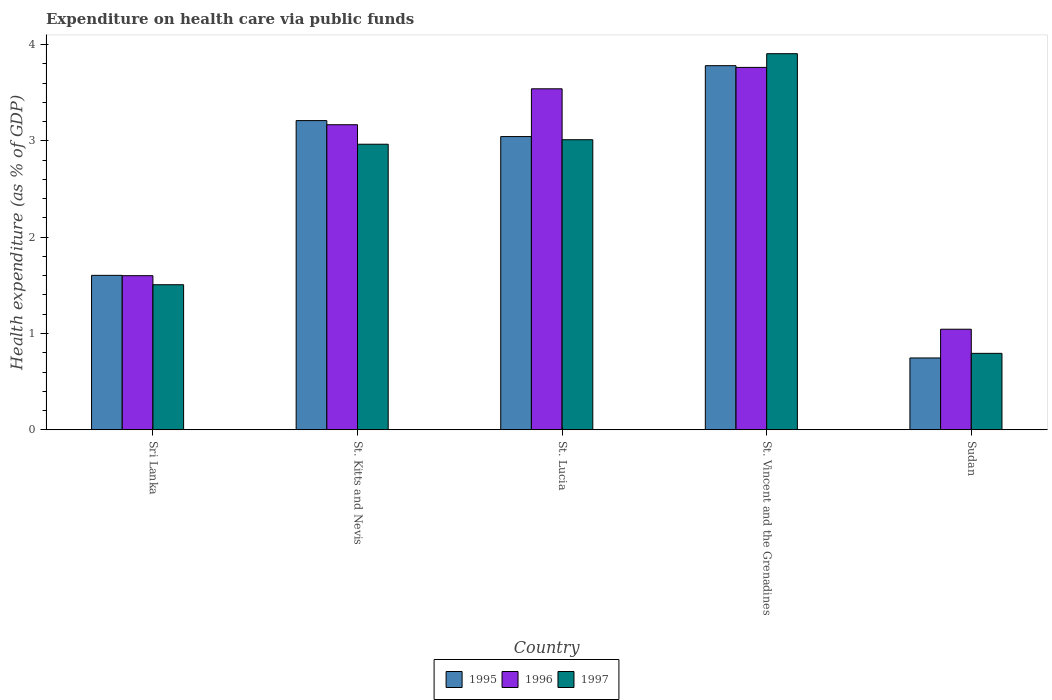How many different coloured bars are there?
Your answer should be compact. 3. Are the number of bars per tick equal to the number of legend labels?
Your answer should be compact. Yes. Are the number of bars on each tick of the X-axis equal?
Offer a very short reply. Yes. How many bars are there on the 1st tick from the left?
Give a very brief answer. 3. What is the label of the 2nd group of bars from the left?
Give a very brief answer. St. Kitts and Nevis. In how many cases, is the number of bars for a given country not equal to the number of legend labels?
Your response must be concise. 0. What is the expenditure made on health care in 1997 in Sri Lanka?
Ensure brevity in your answer.  1.51. Across all countries, what is the maximum expenditure made on health care in 1997?
Your answer should be compact. 3.91. Across all countries, what is the minimum expenditure made on health care in 1995?
Keep it short and to the point. 0.75. In which country was the expenditure made on health care in 1996 maximum?
Keep it short and to the point. St. Vincent and the Grenadines. In which country was the expenditure made on health care in 1995 minimum?
Offer a very short reply. Sudan. What is the total expenditure made on health care in 1996 in the graph?
Make the answer very short. 13.11. What is the difference between the expenditure made on health care in 1996 in Sri Lanka and that in St. Kitts and Nevis?
Ensure brevity in your answer.  -1.57. What is the difference between the expenditure made on health care in 1996 in St. Lucia and the expenditure made on health care in 1995 in Sri Lanka?
Your answer should be very brief. 1.94. What is the average expenditure made on health care in 1997 per country?
Ensure brevity in your answer.  2.44. What is the difference between the expenditure made on health care of/in 1996 and expenditure made on health care of/in 1997 in St. Kitts and Nevis?
Offer a very short reply. 0.2. What is the ratio of the expenditure made on health care in 1995 in St. Lucia to that in St. Vincent and the Grenadines?
Your answer should be compact. 0.81. Is the expenditure made on health care in 1997 in St. Lucia less than that in St. Vincent and the Grenadines?
Give a very brief answer. Yes. Is the difference between the expenditure made on health care in 1996 in St. Kitts and Nevis and St. Lucia greater than the difference between the expenditure made on health care in 1997 in St. Kitts and Nevis and St. Lucia?
Your answer should be very brief. No. What is the difference between the highest and the second highest expenditure made on health care in 1997?
Keep it short and to the point. 0.05. What is the difference between the highest and the lowest expenditure made on health care in 1996?
Provide a short and direct response. 2.72. Is the sum of the expenditure made on health care in 1995 in Sri Lanka and Sudan greater than the maximum expenditure made on health care in 1996 across all countries?
Your response must be concise. No. What does the 1st bar from the left in St. Lucia represents?
Give a very brief answer. 1995. What does the 3rd bar from the right in St. Lucia represents?
Make the answer very short. 1995. How many legend labels are there?
Your answer should be compact. 3. What is the title of the graph?
Make the answer very short. Expenditure on health care via public funds. What is the label or title of the X-axis?
Keep it short and to the point. Country. What is the label or title of the Y-axis?
Ensure brevity in your answer.  Health expenditure (as % of GDP). What is the Health expenditure (as % of GDP) of 1995 in Sri Lanka?
Keep it short and to the point. 1.6. What is the Health expenditure (as % of GDP) of 1996 in Sri Lanka?
Offer a very short reply. 1.6. What is the Health expenditure (as % of GDP) of 1997 in Sri Lanka?
Your answer should be very brief. 1.51. What is the Health expenditure (as % of GDP) of 1995 in St. Kitts and Nevis?
Provide a short and direct response. 3.21. What is the Health expenditure (as % of GDP) of 1996 in St. Kitts and Nevis?
Give a very brief answer. 3.17. What is the Health expenditure (as % of GDP) of 1997 in St. Kitts and Nevis?
Offer a very short reply. 2.96. What is the Health expenditure (as % of GDP) in 1995 in St. Lucia?
Offer a very short reply. 3.04. What is the Health expenditure (as % of GDP) of 1996 in St. Lucia?
Give a very brief answer. 3.54. What is the Health expenditure (as % of GDP) of 1997 in St. Lucia?
Offer a terse response. 3.01. What is the Health expenditure (as % of GDP) in 1995 in St. Vincent and the Grenadines?
Offer a terse response. 3.78. What is the Health expenditure (as % of GDP) in 1996 in St. Vincent and the Grenadines?
Offer a very short reply. 3.76. What is the Health expenditure (as % of GDP) in 1997 in St. Vincent and the Grenadines?
Your answer should be very brief. 3.91. What is the Health expenditure (as % of GDP) in 1995 in Sudan?
Offer a terse response. 0.75. What is the Health expenditure (as % of GDP) in 1996 in Sudan?
Your response must be concise. 1.04. What is the Health expenditure (as % of GDP) in 1997 in Sudan?
Ensure brevity in your answer.  0.79. Across all countries, what is the maximum Health expenditure (as % of GDP) in 1995?
Make the answer very short. 3.78. Across all countries, what is the maximum Health expenditure (as % of GDP) of 1996?
Keep it short and to the point. 3.76. Across all countries, what is the maximum Health expenditure (as % of GDP) of 1997?
Your answer should be very brief. 3.91. Across all countries, what is the minimum Health expenditure (as % of GDP) of 1995?
Offer a very short reply. 0.75. Across all countries, what is the minimum Health expenditure (as % of GDP) of 1996?
Your answer should be very brief. 1.04. Across all countries, what is the minimum Health expenditure (as % of GDP) in 1997?
Your response must be concise. 0.79. What is the total Health expenditure (as % of GDP) of 1995 in the graph?
Your response must be concise. 12.38. What is the total Health expenditure (as % of GDP) of 1996 in the graph?
Your answer should be very brief. 13.11. What is the total Health expenditure (as % of GDP) of 1997 in the graph?
Keep it short and to the point. 12.18. What is the difference between the Health expenditure (as % of GDP) in 1995 in Sri Lanka and that in St. Kitts and Nevis?
Make the answer very short. -1.61. What is the difference between the Health expenditure (as % of GDP) of 1996 in Sri Lanka and that in St. Kitts and Nevis?
Keep it short and to the point. -1.57. What is the difference between the Health expenditure (as % of GDP) of 1997 in Sri Lanka and that in St. Kitts and Nevis?
Your answer should be very brief. -1.46. What is the difference between the Health expenditure (as % of GDP) in 1995 in Sri Lanka and that in St. Lucia?
Offer a very short reply. -1.44. What is the difference between the Health expenditure (as % of GDP) in 1996 in Sri Lanka and that in St. Lucia?
Your answer should be compact. -1.94. What is the difference between the Health expenditure (as % of GDP) of 1997 in Sri Lanka and that in St. Lucia?
Give a very brief answer. -1.51. What is the difference between the Health expenditure (as % of GDP) in 1995 in Sri Lanka and that in St. Vincent and the Grenadines?
Provide a succinct answer. -2.18. What is the difference between the Health expenditure (as % of GDP) of 1996 in Sri Lanka and that in St. Vincent and the Grenadines?
Give a very brief answer. -2.16. What is the difference between the Health expenditure (as % of GDP) of 1997 in Sri Lanka and that in St. Vincent and the Grenadines?
Ensure brevity in your answer.  -2.4. What is the difference between the Health expenditure (as % of GDP) in 1995 in Sri Lanka and that in Sudan?
Offer a very short reply. 0.86. What is the difference between the Health expenditure (as % of GDP) in 1996 in Sri Lanka and that in Sudan?
Offer a terse response. 0.56. What is the difference between the Health expenditure (as % of GDP) in 1997 in Sri Lanka and that in Sudan?
Provide a succinct answer. 0.71. What is the difference between the Health expenditure (as % of GDP) in 1995 in St. Kitts and Nevis and that in St. Lucia?
Provide a succinct answer. 0.17. What is the difference between the Health expenditure (as % of GDP) in 1996 in St. Kitts and Nevis and that in St. Lucia?
Give a very brief answer. -0.37. What is the difference between the Health expenditure (as % of GDP) of 1997 in St. Kitts and Nevis and that in St. Lucia?
Make the answer very short. -0.05. What is the difference between the Health expenditure (as % of GDP) in 1995 in St. Kitts and Nevis and that in St. Vincent and the Grenadines?
Offer a very short reply. -0.57. What is the difference between the Health expenditure (as % of GDP) in 1996 in St. Kitts and Nevis and that in St. Vincent and the Grenadines?
Your answer should be very brief. -0.6. What is the difference between the Health expenditure (as % of GDP) in 1997 in St. Kitts and Nevis and that in St. Vincent and the Grenadines?
Your answer should be compact. -0.94. What is the difference between the Health expenditure (as % of GDP) in 1995 in St. Kitts and Nevis and that in Sudan?
Offer a very short reply. 2.46. What is the difference between the Health expenditure (as % of GDP) of 1996 in St. Kitts and Nevis and that in Sudan?
Your response must be concise. 2.12. What is the difference between the Health expenditure (as % of GDP) of 1997 in St. Kitts and Nevis and that in Sudan?
Your response must be concise. 2.17. What is the difference between the Health expenditure (as % of GDP) in 1995 in St. Lucia and that in St. Vincent and the Grenadines?
Provide a succinct answer. -0.74. What is the difference between the Health expenditure (as % of GDP) of 1996 in St. Lucia and that in St. Vincent and the Grenadines?
Offer a very short reply. -0.22. What is the difference between the Health expenditure (as % of GDP) of 1997 in St. Lucia and that in St. Vincent and the Grenadines?
Ensure brevity in your answer.  -0.89. What is the difference between the Health expenditure (as % of GDP) in 1995 in St. Lucia and that in Sudan?
Your response must be concise. 2.3. What is the difference between the Health expenditure (as % of GDP) in 1996 in St. Lucia and that in Sudan?
Ensure brevity in your answer.  2.5. What is the difference between the Health expenditure (as % of GDP) of 1997 in St. Lucia and that in Sudan?
Your response must be concise. 2.22. What is the difference between the Health expenditure (as % of GDP) in 1995 in St. Vincent and the Grenadines and that in Sudan?
Provide a short and direct response. 3.03. What is the difference between the Health expenditure (as % of GDP) in 1996 in St. Vincent and the Grenadines and that in Sudan?
Your response must be concise. 2.72. What is the difference between the Health expenditure (as % of GDP) in 1997 in St. Vincent and the Grenadines and that in Sudan?
Provide a succinct answer. 3.11. What is the difference between the Health expenditure (as % of GDP) in 1995 in Sri Lanka and the Health expenditure (as % of GDP) in 1996 in St. Kitts and Nevis?
Provide a succinct answer. -1.56. What is the difference between the Health expenditure (as % of GDP) in 1995 in Sri Lanka and the Health expenditure (as % of GDP) in 1997 in St. Kitts and Nevis?
Your answer should be compact. -1.36. What is the difference between the Health expenditure (as % of GDP) of 1996 in Sri Lanka and the Health expenditure (as % of GDP) of 1997 in St. Kitts and Nevis?
Your answer should be compact. -1.36. What is the difference between the Health expenditure (as % of GDP) of 1995 in Sri Lanka and the Health expenditure (as % of GDP) of 1996 in St. Lucia?
Your response must be concise. -1.94. What is the difference between the Health expenditure (as % of GDP) of 1995 in Sri Lanka and the Health expenditure (as % of GDP) of 1997 in St. Lucia?
Keep it short and to the point. -1.41. What is the difference between the Health expenditure (as % of GDP) of 1996 in Sri Lanka and the Health expenditure (as % of GDP) of 1997 in St. Lucia?
Offer a very short reply. -1.41. What is the difference between the Health expenditure (as % of GDP) of 1995 in Sri Lanka and the Health expenditure (as % of GDP) of 1996 in St. Vincent and the Grenadines?
Offer a very short reply. -2.16. What is the difference between the Health expenditure (as % of GDP) of 1995 in Sri Lanka and the Health expenditure (as % of GDP) of 1997 in St. Vincent and the Grenadines?
Offer a very short reply. -2.3. What is the difference between the Health expenditure (as % of GDP) of 1996 in Sri Lanka and the Health expenditure (as % of GDP) of 1997 in St. Vincent and the Grenadines?
Your answer should be very brief. -2.3. What is the difference between the Health expenditure (as % of GDP) in 1995 in Sri Lanka and the Health expenditure (as % of GDP) in 1996 in Sudan?
Your answer should be very brief. 0.56. What is the difference between the Health expenditure (as % of GDP) in 1995 in Sri Lanka and the Health expenditure (as % of GDP) in 1997 in Sudan?
Ensure brevity in your answer.  0.81. What is the difference between the Health expenditure (as % of GDP) in 1996 in Sri Lanka and the Health expenditure (as % of GDP) in 1997 in Sudan?
Provide a short and direct response. 0.81. What is the difference between the Health expenditure (as % of GDP) in 1995 in St. Kitts and Nevis and the Health expenditure (as % of GDP) in 1996 in St. Lucia?
Your answer should be very brief. -0.33. What is the difference between the Health expenditure (as % of GDP) in 1995 in St. Kitts and Nevis and the Health expenditure (as % of GDP) in 1997 in St. Lucia?
Offer a terse response. 0.2. What is the difference between the Health expenditure (as % of GDP) of 1996 in St. Kitts and Nevis and the Health expenditure (as % of GDP) of 1997 in St. Lucia?
Provide a short and direct response. 0.16. What is the difference between the Health expenditure (as % of GDP) of 1995 in St. Kitts and Nevis and the Health expenditure (as % of GDP) of 1996 in St. Vincent and the Grenadines?
Your answer should be compact. -0.55. What is the difference between the Health expenditure (as % of GDP) of 1995 in St. Kitts and Nevis and the Health expenditure (as % of GDP) of 1997 in St. Vincent and the Grenadines?
Your response must be concise. -0.69. What is the difference between the Health expenditure (as % of GDP) in 1996 in St. Kitts and Nevis and the Health expenditure (as % of GDP) in 1997 in St. Vincent and the Grenadines?
Keep it short and to the point. -0.74. What is the difference between the Health expenditure (as % of GDP) in 1995 in St. Kitts and Nevis and the Health expenditure (as % of GDP) in 1996 in Sudan?
Provide a succinct answer. 2.17. What is the difference between the Health expenditure (as % of GDP) of 1995 in St. Kitts and Nevis and the Health expenditure (as % of GDP) of 1997 in Sudan?
Ensure brevity in your answer.  2.42. What is the difference between the Health expenditure (as % of GDP) in 1996 in St. Kitts and Nevis and the Health expenditure (as % of GDP) in 1997 in Sudan?
Offer a very short reply. 2.37. What is the difference between the Health expenditure (as % of GDP) in 1995 in St. Lucia and the Health expenditure (as % of GDP) in 1996 in St. Vincent and the Grenadines?
Give a very brief answer. -0.72. What is the difference between the Health expenditure (as % of GDP) in 1995 in St. Lucia and the Health expenditure (as % of GDP) in 1997 in St. Vincent and the Grenadines?
Make the answer very short. -0.86. What is the difference between the Health expenditure (as % of GDP) in 1996 in St. Lucia and the Health expenditure (as % of GDP) in 1997 in St. Vincent and the Grenadines?
Ensure brevity in your answer.  -0.36. What is the difference between the Health expenditure (as % of GDP) of 1995 in St. Lucia and the Health expenditure (as % of GDP) of 1996 in Sudan?
Your response must be concise. 2. What is the difference between the Health expenditure (as % of GDP) of 1995 in St. Lucia and the Health expenditure (as % of GDP) of 1997 in Sudan?
Ensure brevity in your answer.  2.25. What is the difference between the Health expenditure (as % of GDP) of 1996 in St. Lucia and the Health expenditure (as % of GDP) of 1997 in Sudan?
Give a very brief answer. 2.75. What is the difference between the Health expenditure (as % of GDP) of 1995 in St. Vincent and the Grenadines and the Health expenditure (as % of GDP) of 1996 in Sudan?
Provide a short and direct response. 2.74. What is the difference between the Health expenditure (as % of GDP) in 1995 in St. Vincent and the Grenadines and the Health expenditure (as % of GDP) in 1997 in Sudan?
Give a very brief answer. 2.99. What is the difference between the Health expenditure (as % of GDP) of 1996 in St. Vincent and the Grenadines and the Health expenditure (as % of GDP) of 1997 in Sudan?
Provide a short and direct response. 2.97. What is the average Health expenditure (as % of GDP) of 1995 per country?
Make the answer very short. 2.48. What is the average Health expenditure (as % of GDP) in 1996 per country?
Make the answer very short. 2.62. What is the average Health expenditure (as % of GDP) in 1997 per country?
Keep it short and to the point. 2.44. What is the difference between the Health expenditure (as % of GDP) of 1995 and Health expenditure (as % of GDP) of 1996 in Sri Lanka?
Offer a very short reply. 0. What is the difference between the Health expenditure (as % of GDP) of 1995 and Health expenditure (as % of GDP) of 1997 in Sri Lanka?
Make the answer very short. 0.1. What is the difference between the Health expenditure (as % of GDP) of 1996 and Health expenditure (as % of GDP) of 1997 in Sri Lanka?
Offer a terse response. 0.09. What is the difference between the Health expenditure (as % of GDP) of 1995 and Health expenditure (as % of GDP) of 1996 in St. Kitts and Nevis?
Keep it short and to the point. 0.04. What is the difference between the Health expenditure (as % of GDP) of 1995 and Health expenditure (as % of GDP) of 1997 in St. Kitts and Nevis?
Offer a terse response. 0.25. What is the difference between the Health expenditure (as % of GDP) of 1996 and Health expenditure (as % of GDP) of 1997 in St. Kitts and Nevis?
Keep it short and to the point. 0.2. What is the difference between the Health expenditure (as % of GDP) in 1995 and Health expenditure (as % of GDP) in 1996 in St. Lucia?
Ensure brevity in your answer.  -0.5. What is the difference between the Health expenditure (as % of GDP) in 1995 and Health expenditure (as % of GDP) in 1997 in St. Lucia?
Provide a short and direct response. 0.03. What is the difference between the Health expenditure (as % of GDP) of 1996 and Health expenditure (as % of GDP) of 1997 in St. Lucia?
Offer a terse response. 0.53. What is the difference between the Health expenditure (as % of GDP) of 1995 and Health expenditure (as % of GDP) of 1996 in St. Vincent and the Grenadines?
Your answer should be compact. 0.02. What is the difference between the Health expenditure (as % of GDP) in 1995 and Health expenditure (as % of GDP) in 1997 in St. Vincent and the Grenadines?
Ensure brevity in your answer.  -0.12. What is the difference between the Health expenditure (as % of GDP) in 1996 and Health expenditure (as % of GDP) in 1997 in St. Vincent and the Grenadines?
Ensure brevity in your answer.  -0.14. What is the difference between the Health expenditure (as % of GDP) of 1995 and Health expenditure (as % of GDP) of 1996 in Sudan?
Your answer should be compact. -0.3. What is the difference between the Health expenditure (as % of GDP) in 1995 and Health expenditure (as % of GDP) in 1997 in Sudan?
Offer a very short reply. -0.05. What is the difference between the Health expenditure (as % of GDP) in 1996 and Health expenditure (as % of GDP) in 1997 in Sudan?
Give a very brief answer. 0.25. What is the ratio of the Health expenditure (as % of GDP) in 1995 in Sri Lanka to that in St. Kitts and Nevis?
Make the answer very short. 0.5. What is the ratio of the Health expenditure (as % of GDP) of 1996 in Sri Lanka to that in St. Kitts and Nevis?
Make the answer very short. 0.51. What is the ratio of the Health expenditure (as % of GDP) of 1997 in Sri Lanka to that in St. Kitts and Nevis?
Your response must be concise. 0.51. What is the ratio of the Health expenditure (as % of GDP) in 1995 in Sri Lanka to that in St. Lucia?
Your response must be concise. 0.53. What is the ratio of the Health expenditure (as % of GDP) of 1996 in Sri Lanka to that in St. Lucia?
Provide a short and direct response. 0.45. What is the ratio of the Health expenditure (as % of GDP) in 1997 in Sri Lanka to that in St. Lucia?
Your answer should be compact. 0.5. What is the ratio of the Health expenditure (as % of GDP) of 1995 in Sri Lanka to that in St. Vincent and the Grenadines?
Give a very brief answer. 0.42. What is the ratio of the Health expenditure (as % of GDP) in 1996 in Sri Lanka to that in St. Vincent and the Grenadines?
Keep it short and to the point. 0.43. What is the ratio of the Health expenditure (as % of GDP) of 1997 in Sri Lanka to that in St. Vincent and the Grenadines?
Provide a short and direct response. 0.39. What is the ratio of the Health expenditure (as % of GDP) in 1995 in Sri Lanka to that in Sudan?
Provide a short and direct response. 2.15. What is the ratio of the Health expenditure (as % of GDP) in 1996 in Sri Lanka to that in Sudan?
Your response must be concise. 1.53. What is the ratio of the Health expenditure (as % of GDP) of 1997 in Sri Lanka to that in Sudan?
Provide a succinct answer. 1.9. What is the ratio of the Health expenditure (as % of GDP) in 1995 in St. Kitts and Nevis to that in St. Lucia?
Make the answer very short. 1.05. What is the ratio of the Health expenditure (as % of GDP) in 1996 in St. Kitts and Nevis to that in St. Lucia?
Your answer should be compact. 0.89. What is the ratio of the Health expenditure (as % of GDP) of 1997 in St. Kitts and Nevis to that in St. Lucia?
Provide a succinct answer. 0.98. What is the ratio of the Health expenditure (as % of GDP) of 1995 in St. Kitts and Nevis to that in St. Vincent and the Grenadines?
Offer a terse response. 0.85. What is the ratio of the Health expenditure (as % of GDP) of 1996 in St. Kitts and Nevis to that in St. Vincent and the Grenadines?
Make the answer very short. 0.84. What is the ratio of the Health expenditure (as % of GDP) of 1997 in St. Kitts and Nevis to that in St. Vincent and the Grenadines?
Ensure brevity in your answer.  0.76. What is the ratio of the Health expenditure (as % of GDP) in 1995 in St. Kitts and Nevis to that in Sudan?
Give a very brief answer. 4.3. What is the ratio of the Health expenditure (as % of GDP) in 1996 in St. Kitts and Nevis to that in Sudan?
Offer a very short reply. 3.03. What is the ratio of the Health expenditure (as % of GDP) of 1997 in St. Kitts and Nevis to that in Sudan?
Offer a terse response. 3.74. What is the ratio of the Health expenditure (as % of GDP) in 1995 in St. Lucia to that in St. Vincent and the Grenadines?
Offer a terse response. 0.81. What is the ratio of the Health expenditure (as % of GDP) in 1996 in St. Lucia to that in St. Vincent and the Grenadines?
Your answer should be very brief. 0.94. What is the ratio of the Health expenditure (as % of GDP) of 1997 in St. Lucia to that in St. Vincent and the Grenadines?
Ensure brevity in your answer.  0.77. What is the ratio of the Health expenditure (as % of GDP) of 1995 in St. Lucia to that in Sudan?
Your answer should be compact. 4.08. What is the ratio of the Health expenditure (as % of GDP) in 1996 in St. Lucia to that in Sudan?
Keep it short and to the point. 3.39. What is the ratio of the Health expenditure (as % of GDP) of 1997 in St. Lucia to that in Sudan?
Offer a very short reply. 3.79. What is the ratio of the Health expenditure (as % of GDP) of 1995 in St. Vincent and the Grenadines to that in Sudan?
Ensure brevity in your answer.  5.07. What is the ratio of the Health expenditure (as % of GDP) of 1996 in St. Vincent and the Grenadines to that in Sudan?
Offer a terse response. 3.6. What is the ratio of the Health expenditure (as % of GDP) of 1997 in St. Vincent and the Grenadines to that in Sudan?
Ensure brevity in your answer.  4.92. What is the difference between the highest and the second highest Health expenditure (as % of GDP) in 1995?
Offer a terse response. 0.57. What is the difference between the highest and the second highest Health expenditure (as % of GDP) in 1996?
Give a very brief answer. 0.22. What is the difference between the highest and the second highest Health expenditure (as % of GDP) of 1997?
Give a very brief answer. 0.89. What is the difference between the highest and the lowest Health expenditure (as % of GDP) in 1995?
Keep it short and to the point. 3.03. What is the difference between the highest and the lowest Health expenditure (as % of GDP) in 1996?
Your answer should be very brief. 2.72. What is the difference between the highest and the lowest Health expenditure (as % of GDP) of 1997?
Make the answer very short. 3.11. 